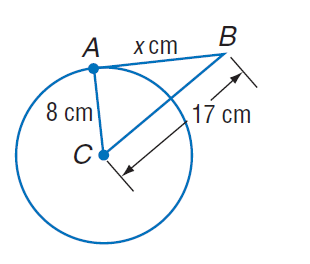Question: Find x. Assume that segments that appear to be tangent are tangent.
Choices:
A. 8
B. 15
C. 16
D. 17
Answer with the letter. Answer: B 